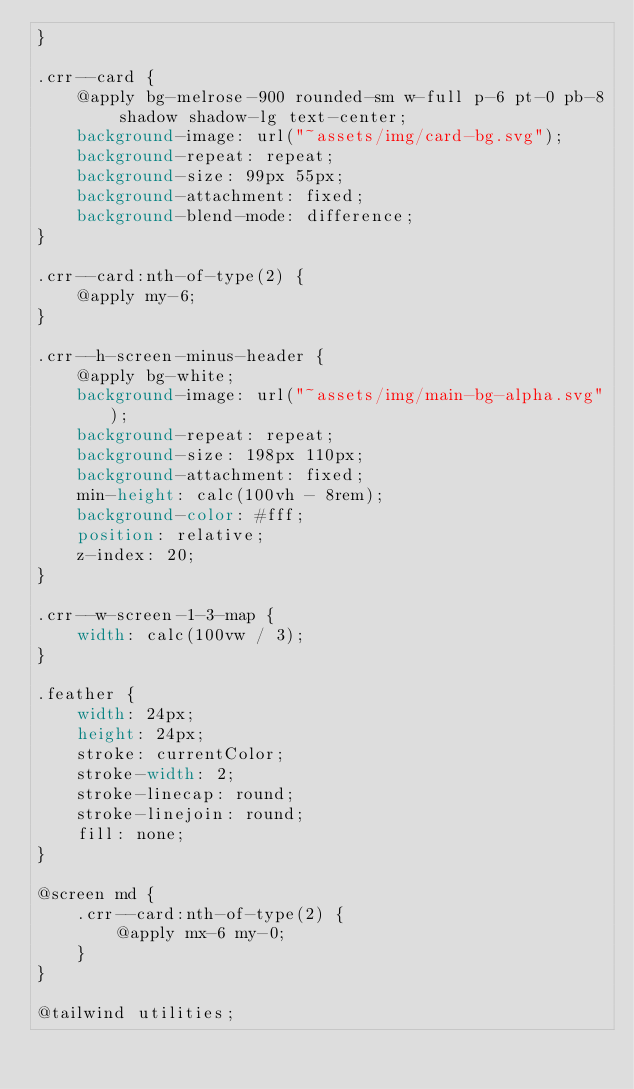<code> <loc_0><loc_0><loc_500><loc_500><_CSS_>}

.crr--card {
	@apply bg-melrose-900 rounded-sm w-full p-6 pt-0 pb-8 shadow shadow-lg text-center;
	background-image: url("~assets/img/card-bg.svg");
	background-repeat: repeat;
	background-size: 99px 55px;
	background-attachment: fixed;
	background-blend-mode: difference;
}

.crr--card:nth-of-type(2) {
	@apply my-6;
}

.crr--h-screen-minus-header {
	@apply bg-white;
	background-image: url("~assets/img/main-bg-alpha.svg");
	background-repeat: repeat;
	background-size: 198px 110px;
	background-attachment: fixed;
	min-height: calc(100vh - 8rem);
	background-color: #fff;
	position: relative;
	z-index: 20;
}

.crr--w-screen-1-3-map {
	width: calc(100vw / 3);
}

.feather {
	width: 24px;
	height: 24px;
	stroke: currentColor;
	stroke-width: 2;
	stroke-linecap: round;
	stroke-linejoin: round;
	fill: none;
}

@screen md {
	.crr--card:nth-of-type(2) {
		@apply mx-6 my-0;
	}
}

@tailwind utilities;
</code> 